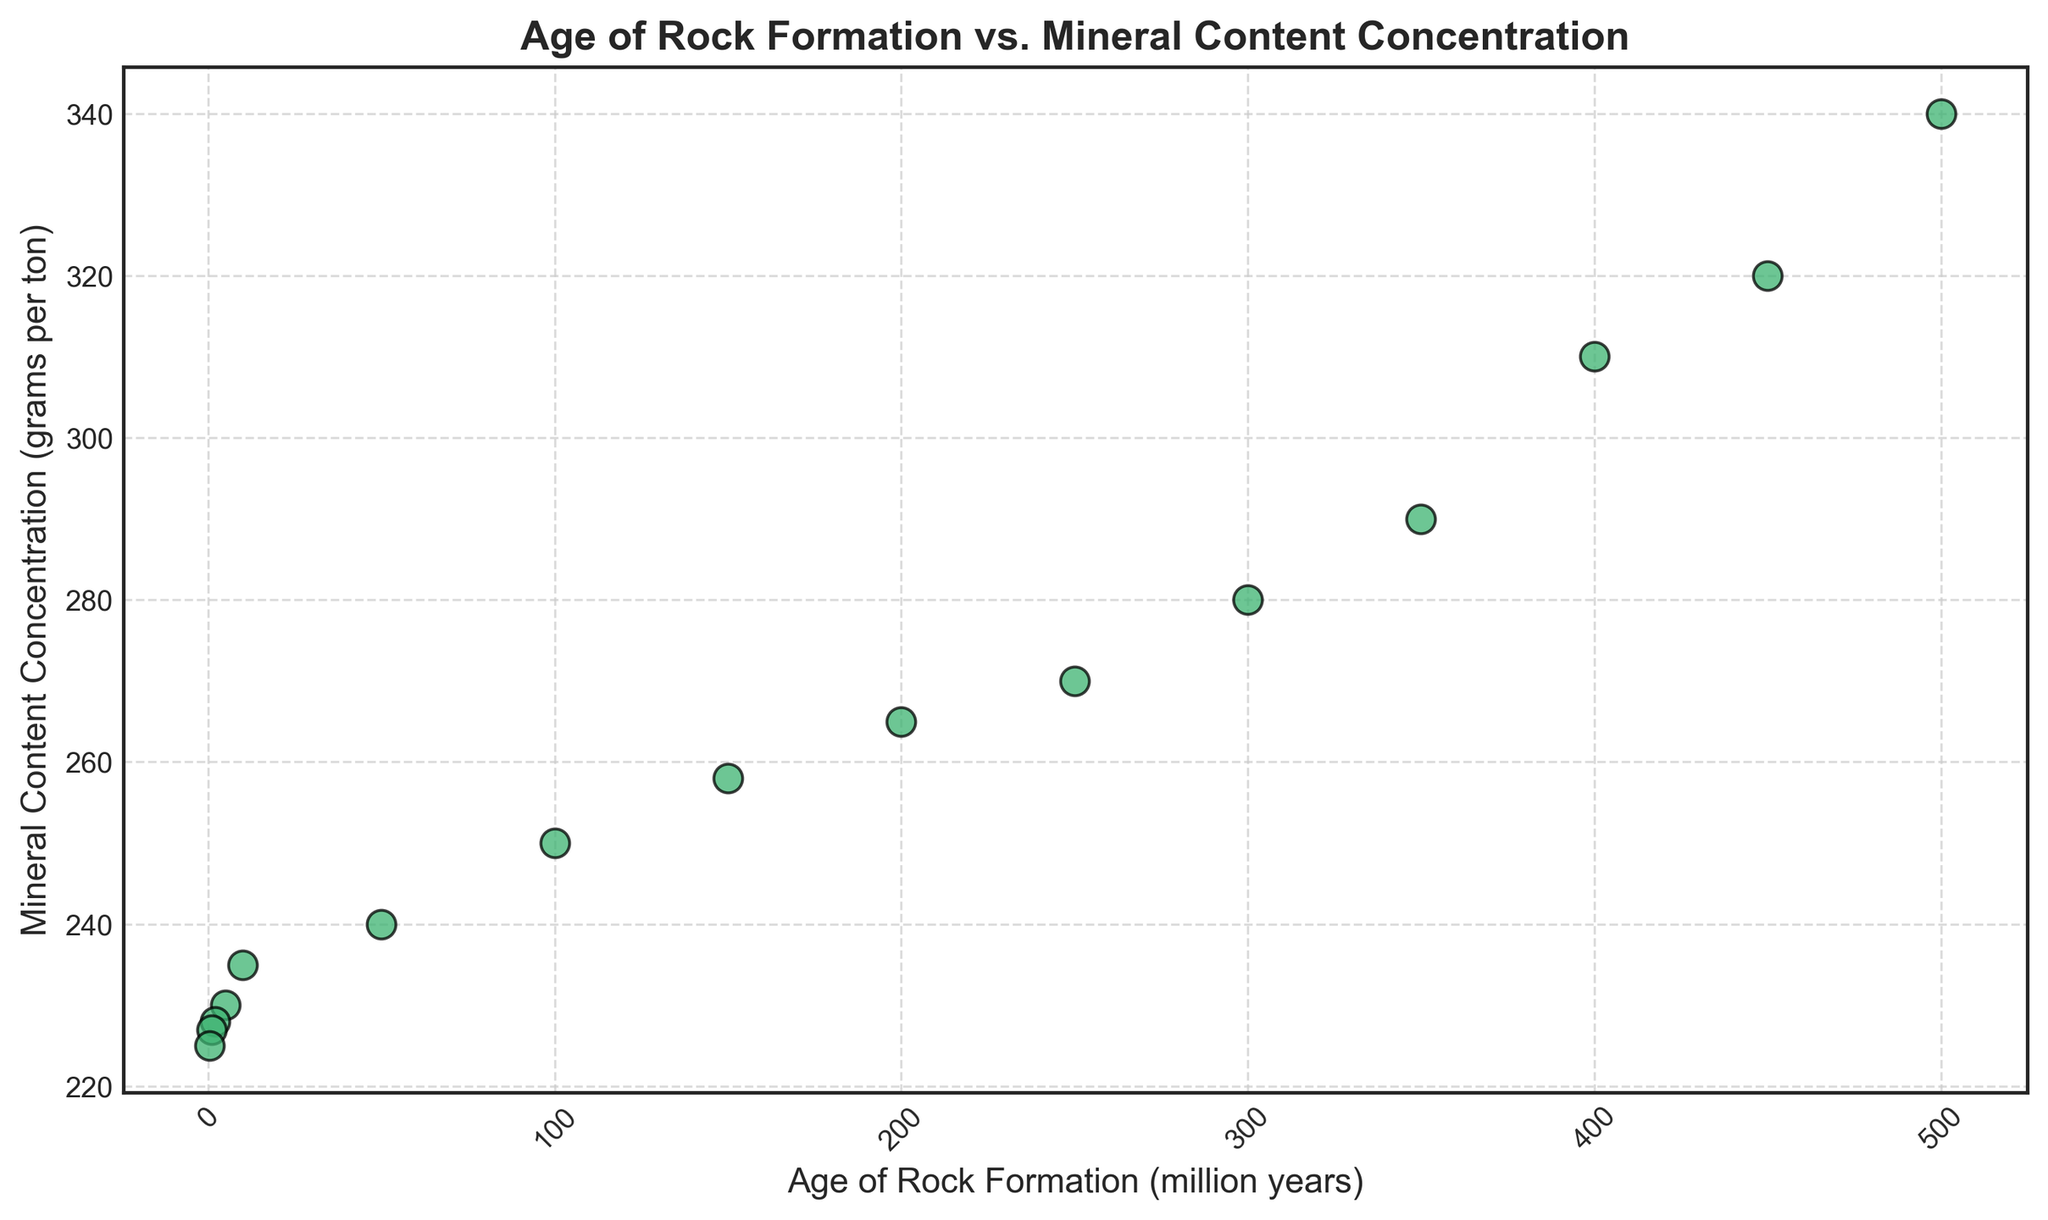What is the mineral content concentration for the rock formation aged 500 million years? Locate the point corresponding to 500 million years on the x-axis, then find its corresponding y-value.
Answer: 340 grams per ton For which age of rock formation is the mineral content concentration closest to 260 grams per ton? Find the y-axis value closest to 260 grams per ton and then track its corresponding x-axis value.
Answer: 150 million years Between rock formations aged 100 million years and 50 million years, which has higher mineral content concentration? Compare the y-values for 100 million years and 50 million years.
Answer: 100 million years By how much does the mineral content concentration decrease from rock formations aged 5 million years to 1 million years? Determine the difference between the y-values for 5 million years (230) and 1 million years (227).
Answer: 3 grams per ton What is the average mineral content concentration of rock formations aged between 200 and 50 million years? Find the y-values for ages 200, 150, 100, and 50 million years, sum them (265 + 258 + 250 + 240 = 1013), and divide by the number of points (4).
Answer: 253.25 grams per ton Is the mineral content concentration trend increasing or decreasing with the age of rock formations? Observe the general direction of the data points from the left (older) to the right (newer).
Answer: Decreasing What is the visual marker used for plotting data points? Identify the shape and color of the markers used in the scatter plot.
Answer: Green circle with a black edge Which age of rock formation has the lowest mineral content concentration? Find the smallest y-value and its corresponding x-axis value.
Answer: 0.5 million years For how many rock formations is the mineral content concentration above 300 grams per ton? Count the number of points with y-values greater than 300.
Answer: 3 What can you infer about the relationship between the age of rock formations and mineral content concentration from the scatter plot? Describe the general trend observed by tracking the position of the data points relative to their axes.
Answer: As the age decreases, mineral content concentration mostly decreases 